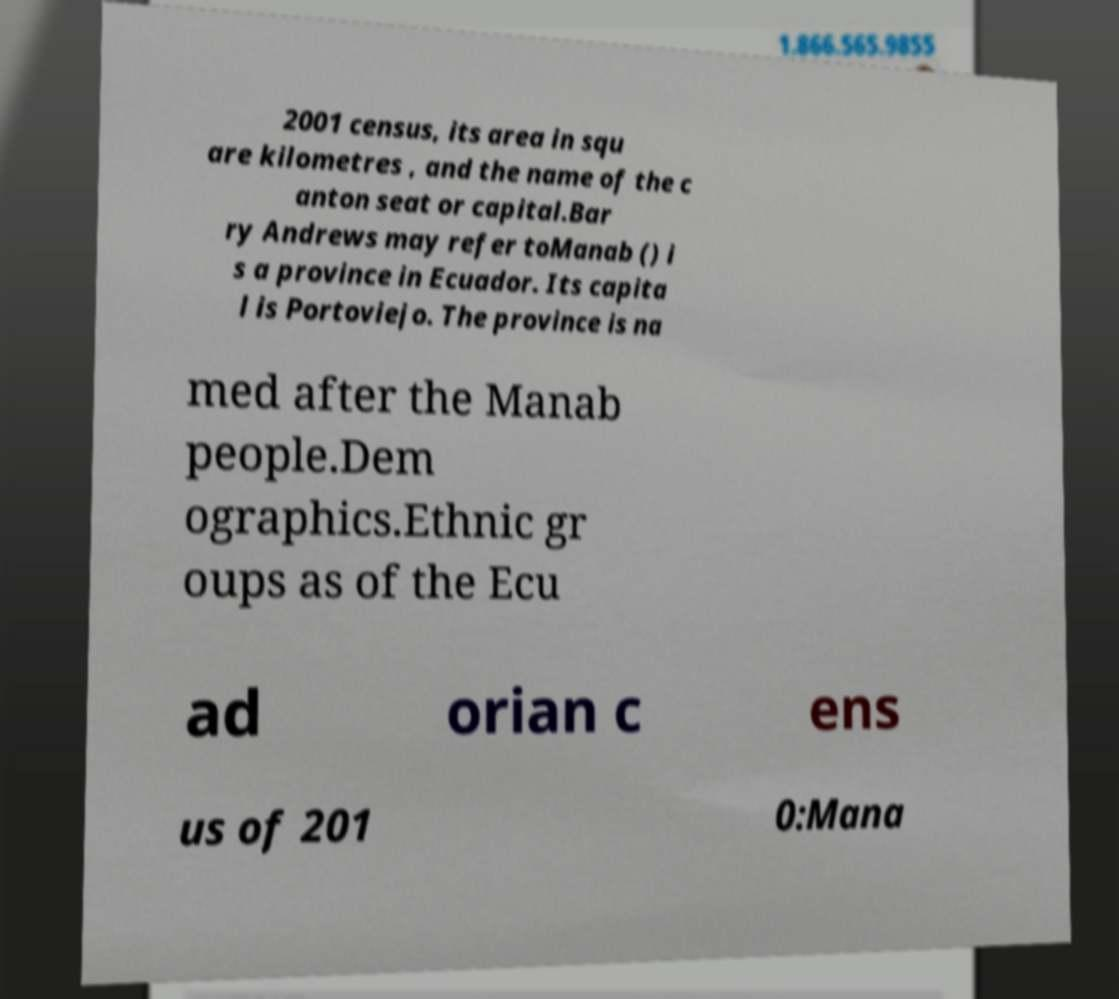Please identify and transcribe the text found in this image. 2001 census, its area in squ are kilometres , and the name of the c anton seat or capital.Bar ry Andrews may refer toManab () i s a province in Ecuador. Its capita l is Portoviejo. The province is na med after the Manab people.Dem ographics.Ethnic gr oups as of the Ecu ad orian c ens us of 201 0:Mana 